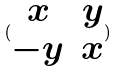<formula> <loc_0><loc_0><loc_500><loc_500>( \begin{matrix} x & y \\ - y & x \end{matrix} )</formula> 